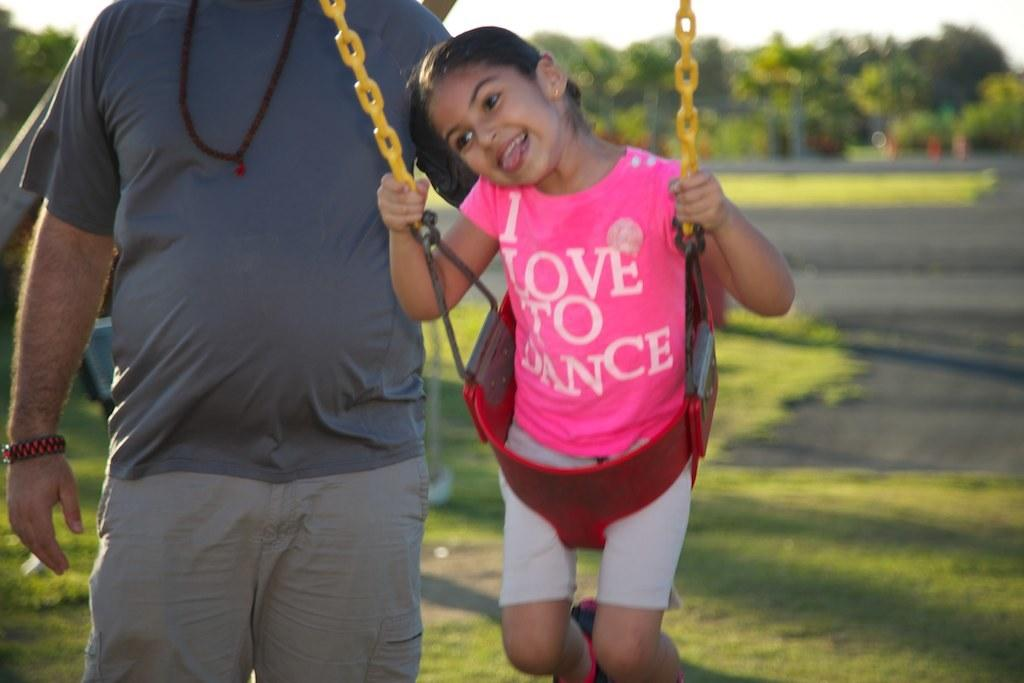How many people are in the image? There are two people in the image. Can you describe the appearance of the girl in the image? The girl is wearing a pink dress. What is the man wearing in the image? The man is wearing a blue t-shirt. What type of natural environment is visible in the image? There is grass, trees, and the sky visible in the image. How many chickens are present in the image? There are no chickens present in the image. What type of approval is the man seeking from the girl in the image? There is no indication in the image that the man is seeking approval from the girl. 